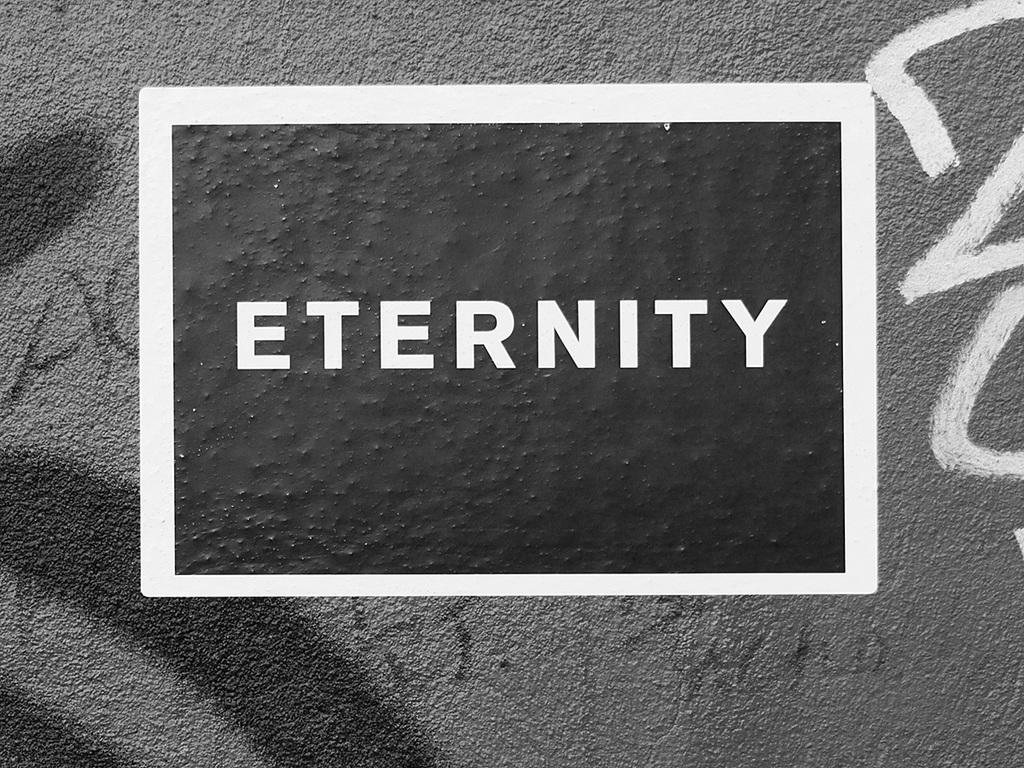<image>
Summarize the visual content of the image. An ad shows an Eternity logo on a gray background. 